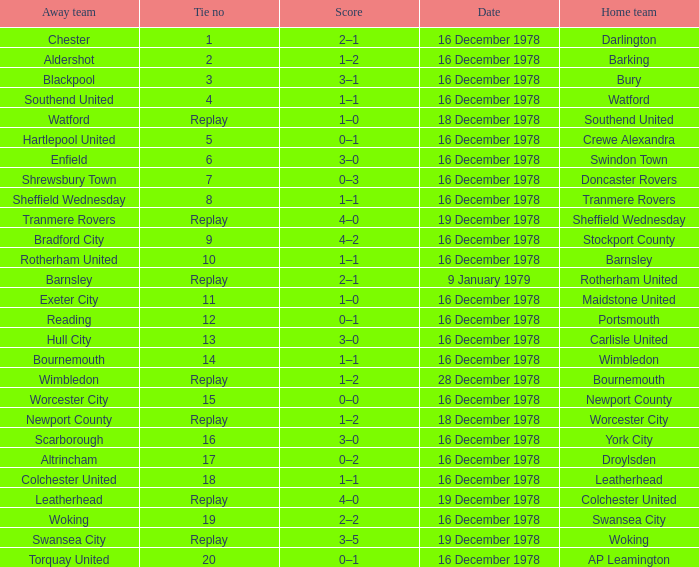What date had a tie no of replay, and an away team of watford? 18 December 1978. Parse the full table. {'header': ['Away team', 'Tie no', 'Score', 'Date', 'Home team'], 'rows': [['Chester', '1', '2–1', '16 December 1978', 'Darlington'], ['Aldershot', '2', '1–2', '16 December 1978', 'Barking'], ['Blackpool', '3', '3–1', '16 December 1978', 'Bury'], ['Southend United', '4', '1–1', '16 December 1978', 'Watford'], ['Watford', 'Replay', '1–0', '18 December 1978', 'Southend United'], ['Hartlepool United', '5', '0–1', '16 December 1978', 'Crewe Alexandra'], ['Enfield', '6', '3–0', '16 December 1978', 'Swindon Town'], ['Shrewsbury Town', '7', '0–3', '16 December 1978', 'Doncaster Rovers'], ['Sheffield Wednesday', '8', '1–1', '16 December 1978', 'Tranmere Rovers'], ['Tranmere Rovers', 'Replay', '4–0', '19 December 1978', 'Sheffield Wednesday'], ['Bradford City', '9', '4–2', '16 December 1978', 'Stockport County'], ['Rotherham United', '10', '1–1', '16 December 1978', 'Barnsley'], ['Barnsley', 'Replay', '2–1', '9 January 1979', 'Rotherham United'], ['Exeter City', '11', '1–0', '16 December 1978', 'Maidstone United'], ['Reading', '12', '0–1', '16 December 1978', 'Portsmouth'], ['Hull City', '13', '3–0', '16 December 1978', 'Carlisle United'], ['Bournemouth', '14', '1–1', '16 December 1978', 'Wimbledon'], ['Wimbledon', 'Replay', '1–2', '28 December 1978', 'Bournemouth'], ['Worcester City', '15', '0–0', '16 December 1978', 'Newport County'], ['Newport County', 'Replay', '1–2', '18 December 1978', 'Worcester City'], ['Scarborough', '16', '3–0', '16 December 1978', 'York City'], ['Altrincham', '17', '0–2', '16 December 1978', 'Droylsden'], ['Colchester United', '18', '1–1', '16 December 1978', 'Leatherhead'], ['Leatherhead', 'Replay', '4–0', '19 December 1978', 'Colchester United'], ['Woking', '19', '2–2', '16 December 1978', 'Swansea City'], ['Swansea City', 'Replay', '3–5', '19 December 1978', 'Woking'], ['Torquay United', '20', '0–1', '16 December 1978', 'AP Leamington']]} 